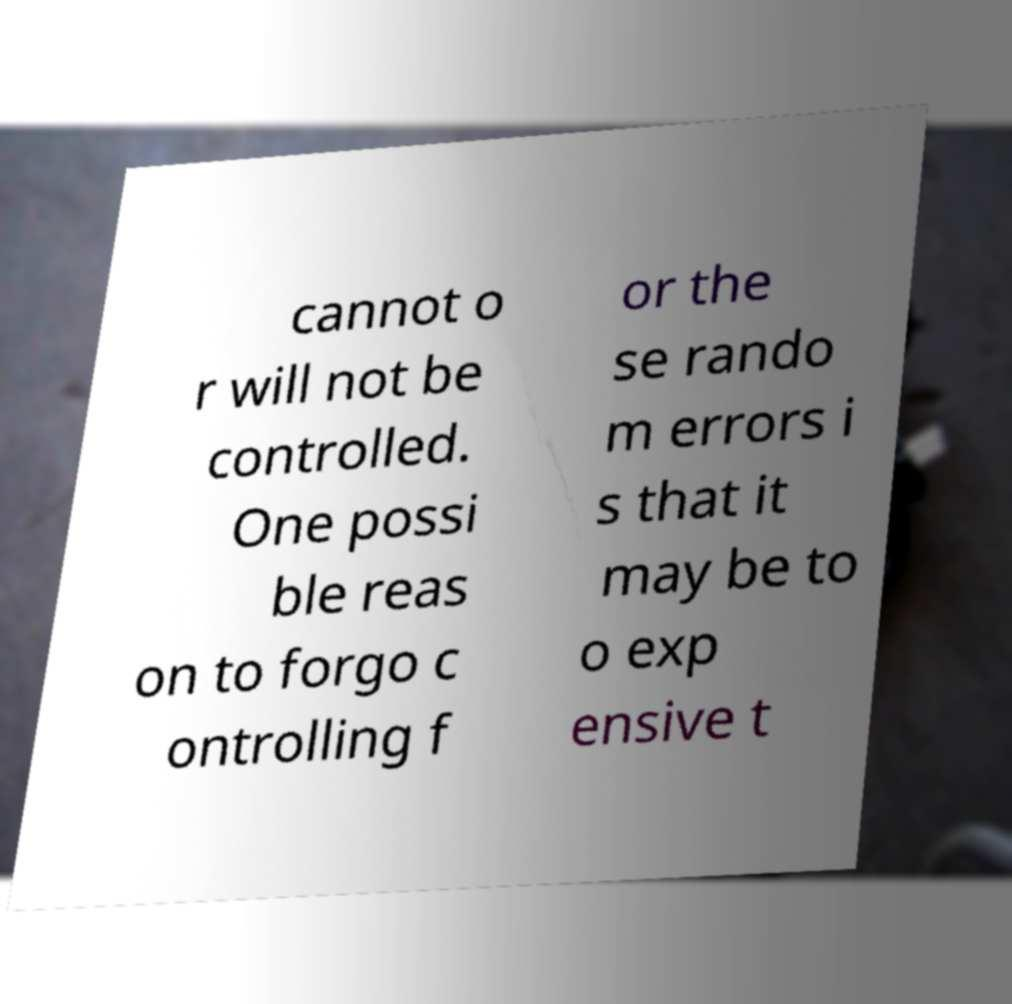What messages or text are displayed in this image? I need them in a readable, typed format. cannot o r will not be controlled. One possi ble reas on to forgo c ontrolling f or the se rando m errors i s that it may be to o exp ensive t 